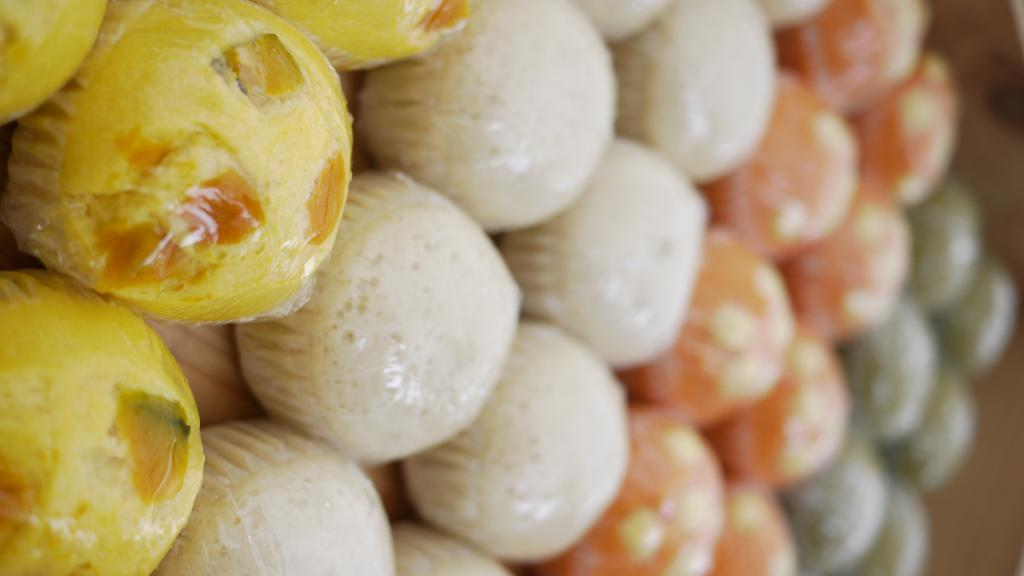What colors can be seen in the food items in the image? The food items in the image are in yellow, white, orange, and green colors. Can you describe the appearance of the food items in the image? The close view of the food items is slightly blurred. What type of instrument is being played by the food items in the image? There are no instruments or people playing them in the image; it only features food items in various colors. 